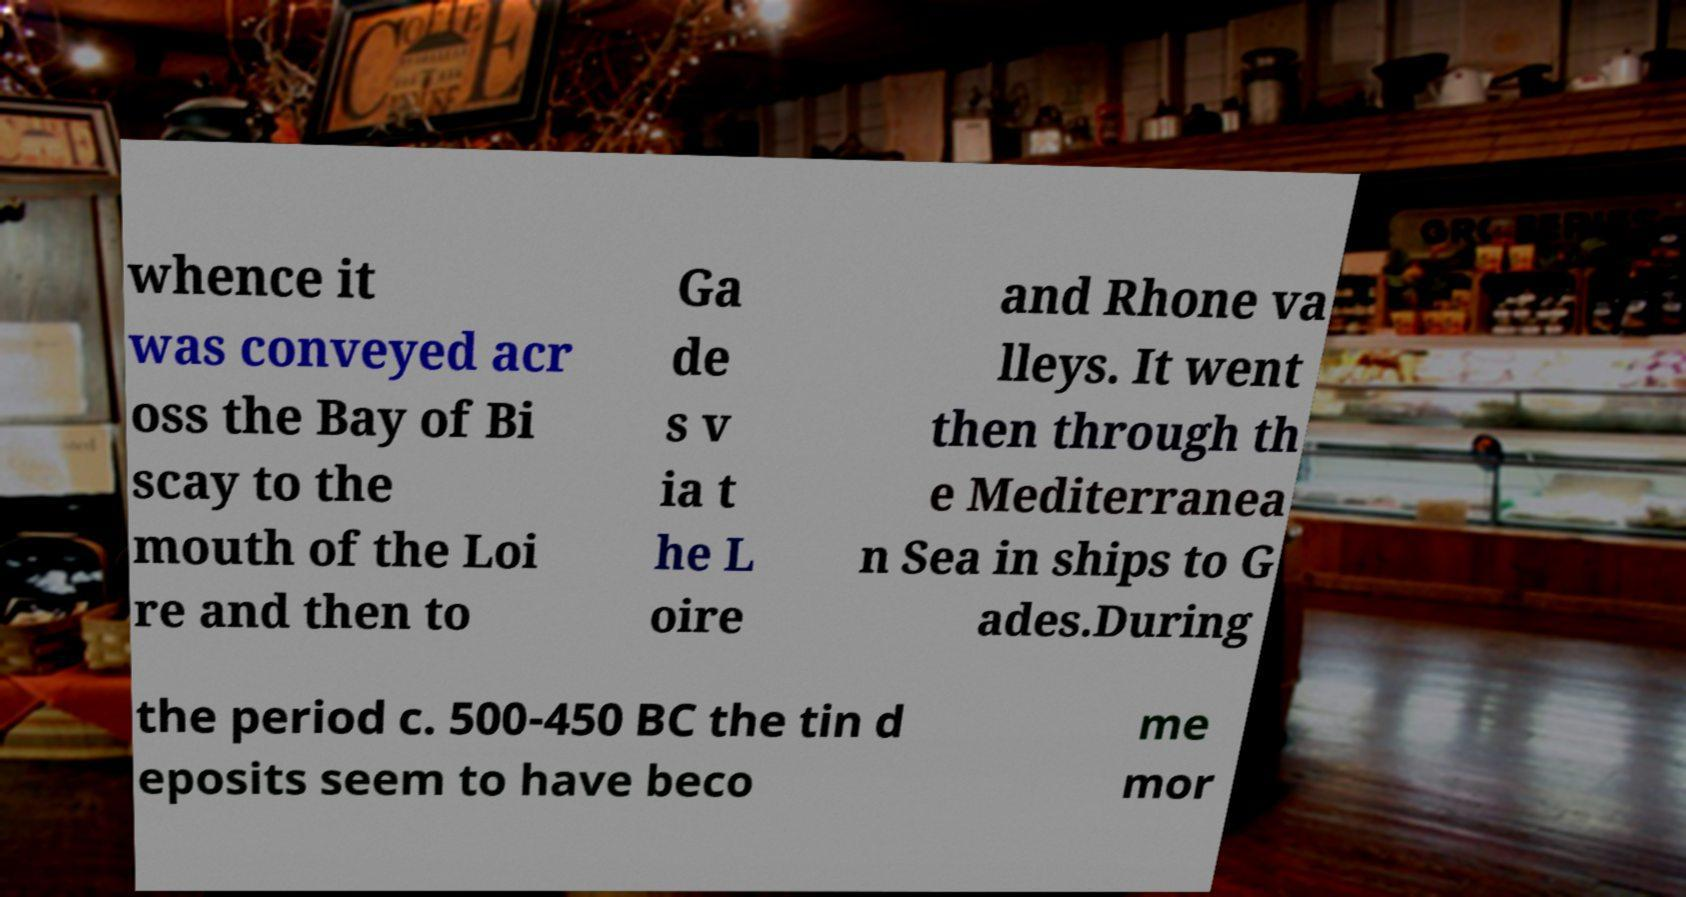I need the written content from this picture converted into text. Can you do that? whence it was conveyed acr oss the Bay of Bi scay to the mouth of the Loi re and then to Ga de s v ia t he L oire and Rhone va lleys. It went then through th e Mediterranea n Sea in ships to G ades.During the period c. 500-450 BC the tin d eposits seem to have beco me mor 